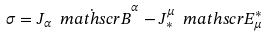<formula> <loc_0><loc_0><loc_500><loc_500>\sigma = J _ { \alpha } \dot { \ m a t h s c r { B } } ^ { \alpha } - J _ { \ast } ^ { \mu } \ m a t h s c r { E } ^ { \ast } _ { \mu }</formula> 